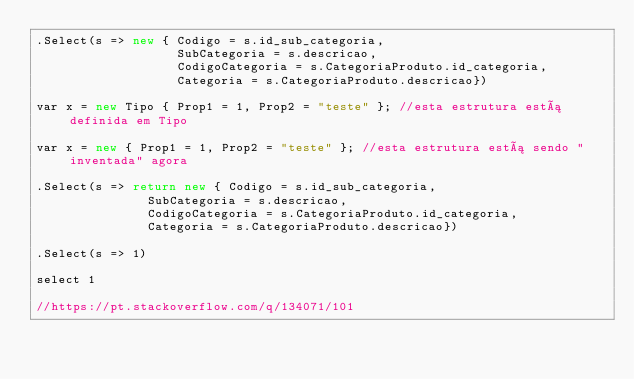<code> <loc_0><loc_0><loc_500><loc_500><_C#_>.Select(s => new { Codigo = s.id_sub_categoria,
                   SubCategoria = s.descricao,
                   CodigoCategoria = s.CategoriaProduto.id_categoria,
                   Categoria = s.CategoriaProduto.descricao})

var x = new Tipo { Prop1 = 1, Prop2 = "teste" }; //esta estrutura está definida em Tipo

var x = new { Prop1 = 1, Prop2 = "teste" }; //esta estrutura está sendo "inventada" agora

.Select(s => return new { Codigo = s.id_sub_categoria,
               SubCategoria = s.descricao,
               CodigoCategoria = s.CategoriaProduto.id_categoria,
               Categoria = s.CategoriaProduto.descricao})

.Select(s => 1)

select 1

//https://pt.stackoverflow.com/q/134071/101
</code> 